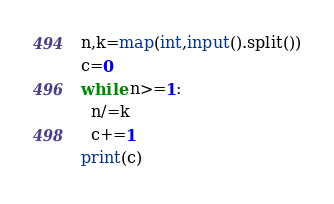<code> <loc_0><loc_0><loc_500><loc_500><_Python_>n,k=map(int,input().split())
c=0
while n>=1:
  n/=k
  c+=1
print(c)</code> 